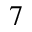Convert formula to latex. <formula><loc_0><loc_0><loc_500><loc_500>^ { 7 }</formula> 